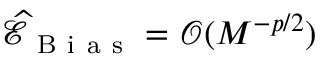<formula> <loc_0><loc_0><loc_500><loc_500>\widehat { \mathcal { E } } _ { B i a s } = \mathcal { O } ( M ^ { - p / 2 } )</formula> 